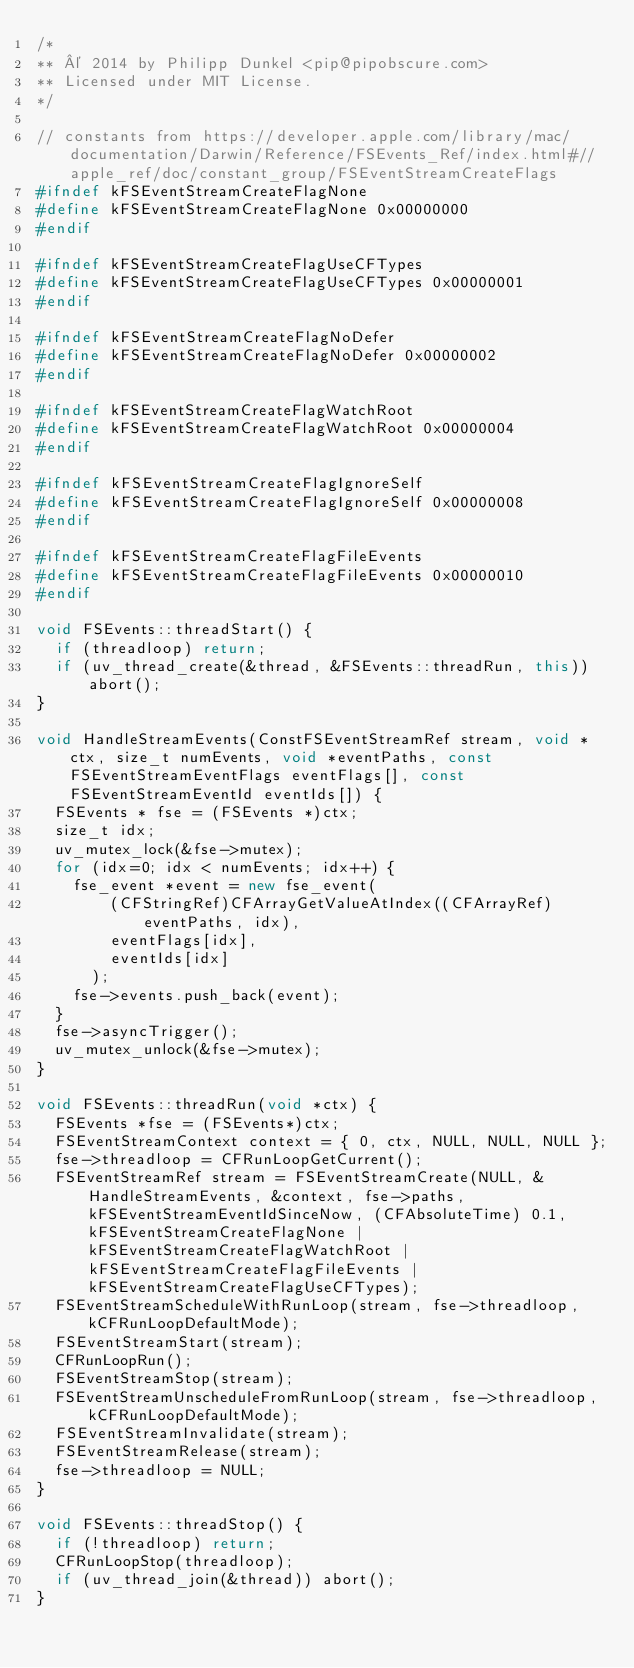Convert code to text. <code><loc_0><loc_0><loc_500><loc_500><_C++_>/*
** © 2014 by Philipp Dunkel <pip@pipobscure.com>
** Licensed under MIT License.
*/

// constants from https://developer.apple.com/library/mac/documentation/Darwin/Reference/FSEvents_Ref/index.html#//apple_ref/doc/constant_group/FSEventStreamCreateFlags
#ifndef kFSEventStreamCreateFlagNone
#define kFSEventStreamCreateFlagNone 0x00000000
#endif

#ifndef kFSEventStreamCreateFlagUseCFTypes
#define kFSEventStreamCreateFlagUseCFTypes 0x00000001
#endif

#ifndef kFSEventStreamCreateFlagNoDefer
#define kFSEventStreamCreateFlagNoDefer 0x00000002
#endif

#ifndef kFSEventStreamCreateFlagWatchRoot
#define kFSEventStreamCreateFlagWatchRoot 0x00000004
#endif

#ifndef kFSEventStreamCreateFlagIgnoreSelf
#define kFSEventStreamCreateFlagIgnoreSelf 0x00000008
#endif

#ifndef kFSEventStreamCreateFlagFileEvents
#define kFSEventStreamCreateFlagFileEvents 0x00000010
#endif

void FSEvents::threadStart() {
  if (threadloop) return;
  if (uv_thread_create(&thread, &FSEvents::threadRun, this)) abort();
}

void HandleStreamEvents(ConstFSEventStreamRef stream, void *ctx, size_t numEvents, void *eventPaths, const FSEventStreamEventFlags eventFlags[], const FSEventStreamEventId eventIds[]) {
  FSEvents * fse = (FSEvents *)ctx;
  size_t idx;
  uv_mutex_lock(&fse->mutex);
  for (idx=0; idx < numEvents; idx++) {
    fse_event *event = new fse_event(
        (CFStringRef)CFArrayGetValueAtIndex((CFArrayRef)eventPaths, idx),
        eventFlags[idx],
        eventIds[idx]
      );
    fse->events.push_back(event);
  }
  fse->asyncTrigger();
  uv_mutex_unlock(&fse->mutex);
}

void FSEvents::threadRun(void *ctx) {
  FSEvents *fse = (FSEvents*)ctx;
  FSEventStreamContext context = { 0, ctx, NULL, NULL, NULL };
  fse->threadloop = CFRunLoopGetCurrent();
  FSEventStreamRef stream = FSEventStreamCreate(NULL, &HandleStreamEvents, &context, fse->paths, kFSEventStreamEventIdSinceNow, (CFAbsoluteTime) 0.1, kFSEventStreamCreateFlagNone | kFSEventStreamCreateFlagWatchRoot | kFSEventStreamCreateFlagFileEvents | kFSEventStreamCreateFlagUseCFTypes);
  FSEventStreamScheduleWithRunLoop(stream, fse->threadloop, kCFRunLoopDefaultMode);
  FSEventStreamStart(stream);
  CFRunLoopRun();
  FSEventStreamStop(stream);
  FSEventStreamUnscheduleFromRunLoop(stream, fse->threadloop, kCFRunLoopDefaultMode);
  FSEventStreamInvalidate(stream);
  FSEventStreamRelease(stream);
  fse->threadloop = NULL;
}

void FSEvents::threadStop() {
  if (!threadloop) return;
  CFRunLoopStop(threadloop);
  if (uv_thread_join(&thread)) abort();
}
</code> 